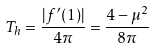<formula> <loc_0><loc_0><loc_500><loc_500>T _ { h } = \frac { | f ^ { \prime } ( 1 ) | } { 4 \pi } = \frac { 4 - \mu ^ { 2 } } { 8 \pi }</formula> 